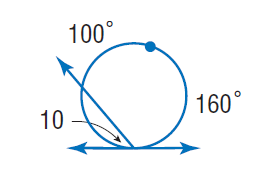Question: Find \angle 10.
Choices:
A. 50
B. 80
C. 100
D. 160
Answer with the letter. Answer: A 